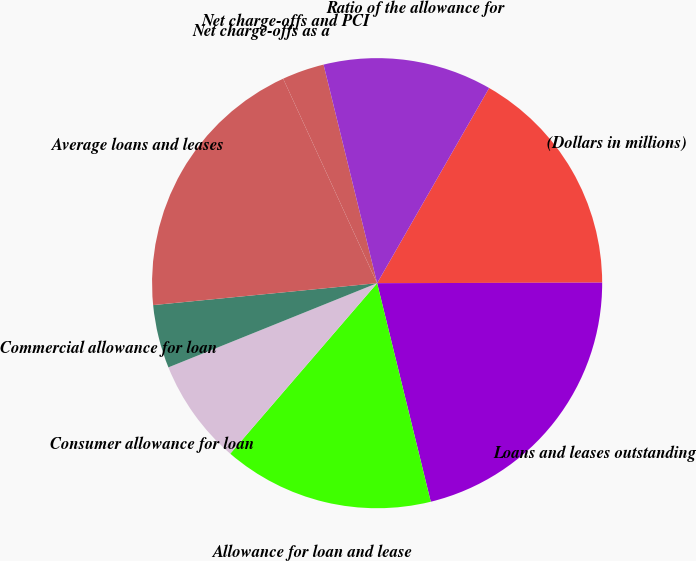Convert chart to OTSL. <chart><loc_0><loc_0><loc_500><loc_500><pie_chart><fcel>(Dollars in millions)<fcel>Loans and leases outstanding<fcel>Allowance for loan and lease<fcel>Consumer allowance for loan<fcel>Commercial allowance for loan<fcel>Average loans and leases<fcel>Net charge-offs as a<fcel>Net charge-offs and PCI<fcel>Ratio of the allowance for<nl><fcel>16.67%<fcel>21.21%<fcel>15.15%<fcel>7.58%<fcel>4.55%<fcel>19.7%<fcel>0.0%<fcel>3.03%<fcel>12.12%<nl></chart> 